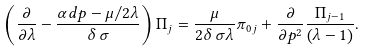Convert formula to latex. <formula><loc_0><loc_0><loc_500><loc_500>\left ( \frac { \partial } { \partial \lambda } - \frac { \alpha d p - \mu / 2 \lambda } { \delta \, \sigma } \right ) { \Pi } _ { j } = \frac { \mu } { 2 \delta \, \sigma \lambda } { { \pi } _ { 0 } } _ { j } + \frac { \partial } { \partial p ^ { 2 } } \frac { { \Pi } _ { j - 1 } } { \left ( \lambda - 1 \right ) } .</formula> 